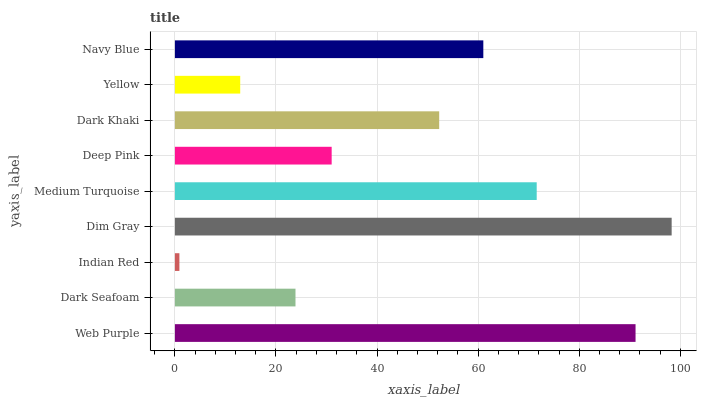Is Indian Red the minimum?
Answer yes or no. Yes. Is Dim Gray the maximum?
Answer yes or no. Yes. Is Dark Seafoam the minimum?
Answer yes or no. No. Is Dark Seafoam the maximum?
Answer yes or no. No. Is Web Purple greater than Dark Seafoam?
Answer yes or no. Yes. Is Dark Seafoam less than Web Purple?
Answer yes or no. Yes. Is Dark Seafoam greater than Web Purple?
Answer yes or no. No. Is Web Purple less than Dark Seafoam?
Answer yes or no. No. Is Dark Khaki the high median?
Answer yes or no. Yes. Is Dark Khaki the low median?
Answer yes or no. Yes. Is Indian Red the high median?
Answer yes or no. No. Is Medium Turquoise the low median?
Answer yes or no. No. 